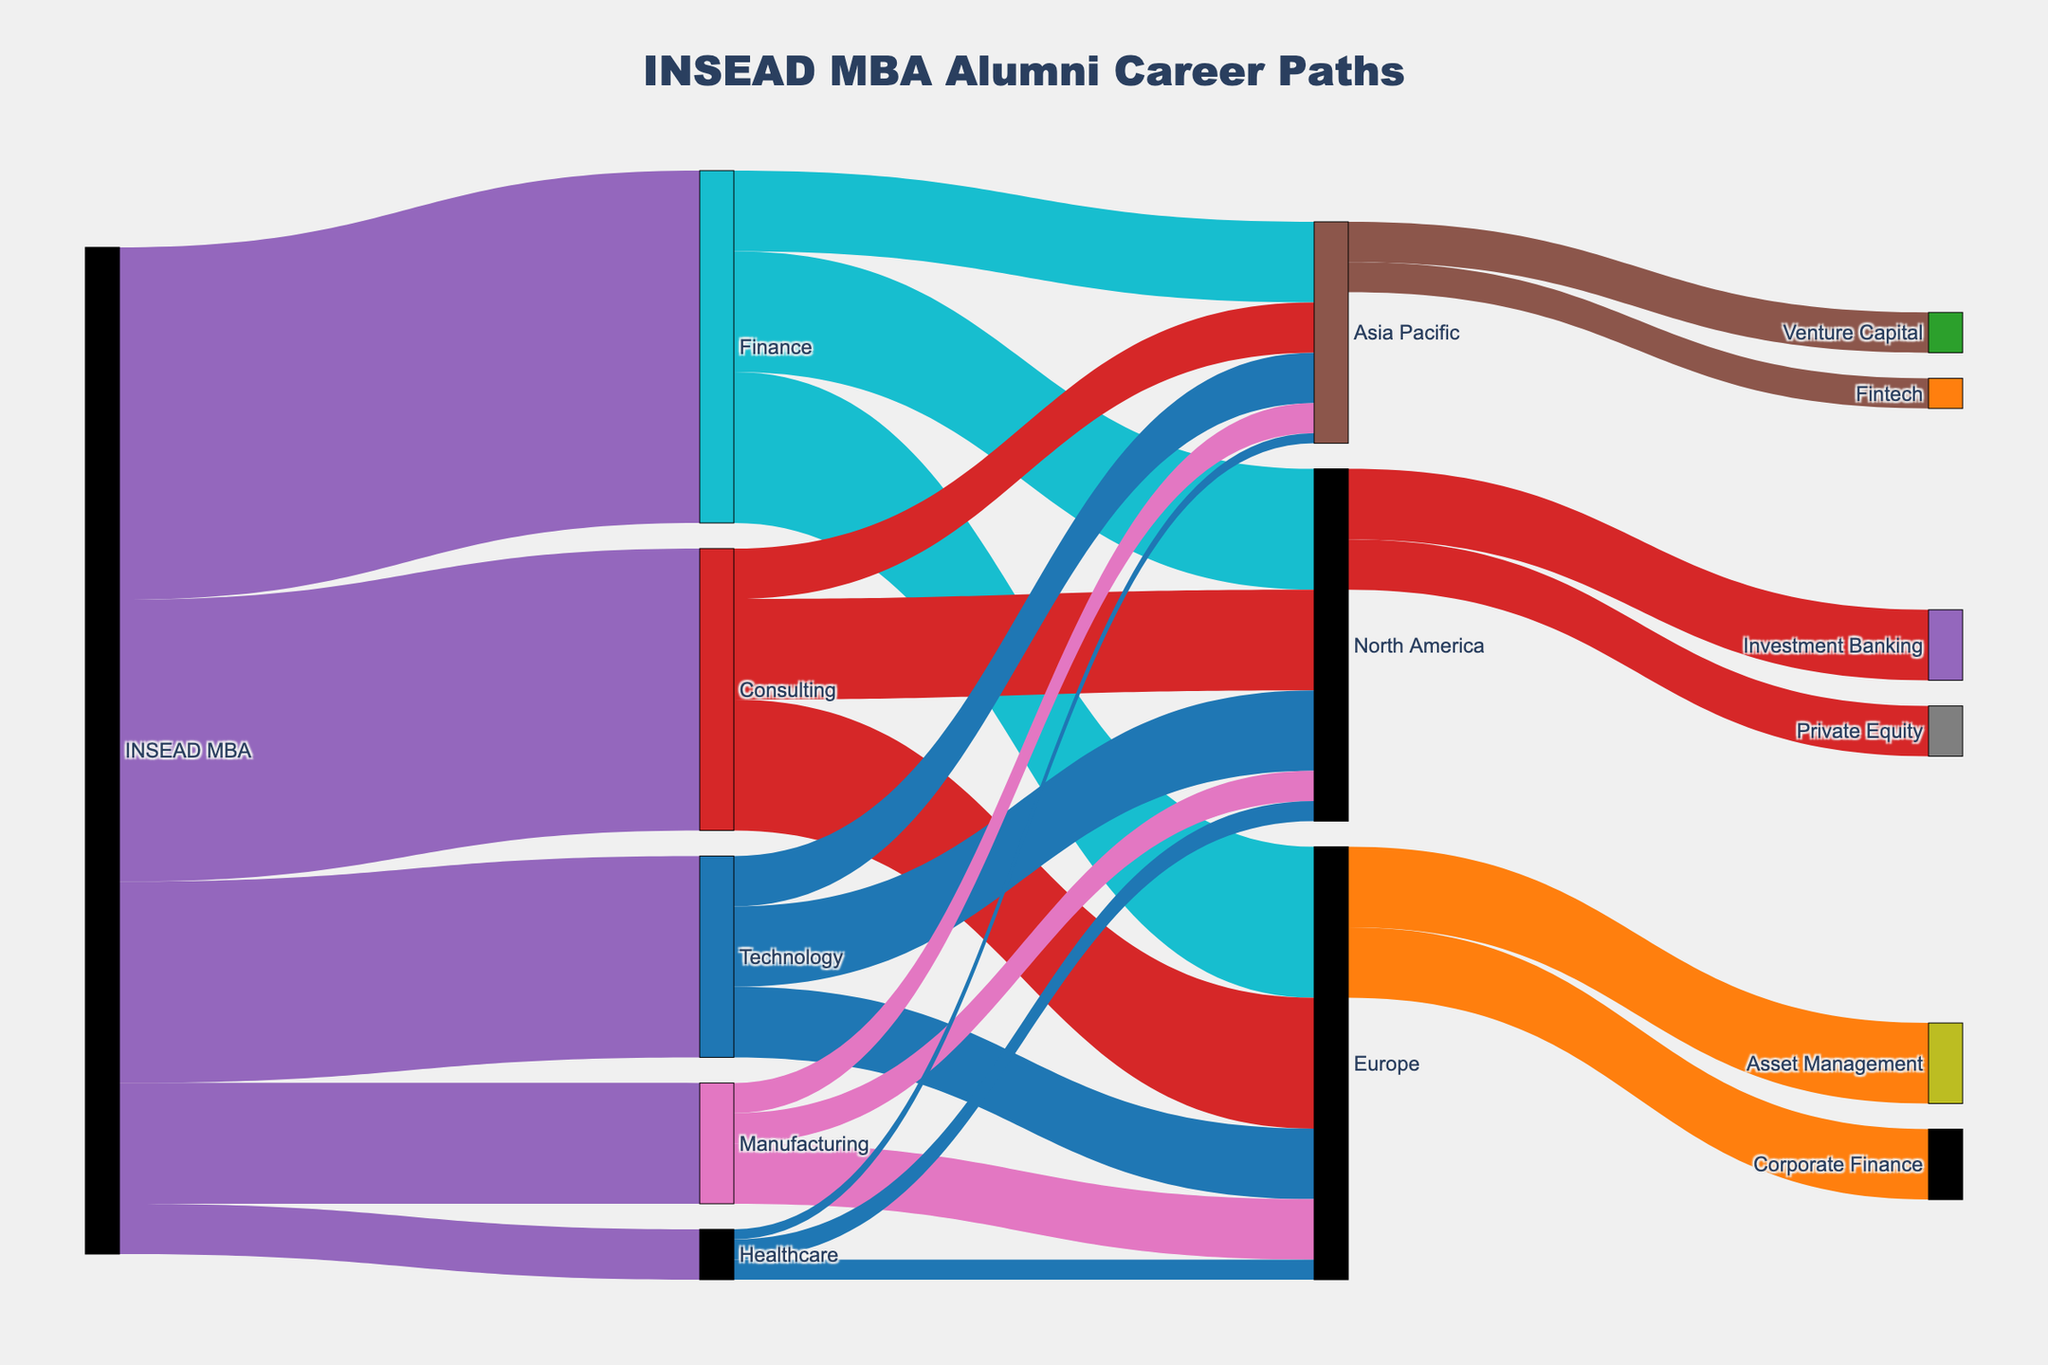what are the top three industries where INSEAD MBA alumni go? By examining the Sankey diagram, we can see the flows from "INSEAD MBA" to different industries. The three industries with the largest flows (highest values) connected to "INSEAD MBA" are Finance (350), Consulting (280), and Technology (200)
Answer: Finance, Consulting, Technology which region has the highest number of INSEAD MBA alumni working in the Consulting industry? Looking at the flows from "Consulting" to different regions, the values are Europe (130), North America (100), and Asia Pacific (50). Europe has the highest number of MBA alumni working in Consulting
Answer: Europe how many INSEAD MBA alumni are working in North America in the Finance and Technology industries combined? First, find the values of "Finance" to "North America" (120) and "Technology" to "North America" (80). Adding them together, we get 120 + 80 = 200
Answer: 200 where do the majority of Technology industry alumni end up region-wise? Examine the flows from "Technology" to different regions. The values are North America (80), Europe (70), and Asia Pacific (50). The majority go to North America
Answer: North America what is the combined value for INSEAD MBA alumni in Manufacturing industries across all regions? Look at the flows from "Manufacturing" to North America (30), Europe (60), and Asia Pacific (30). Adding these together, 30 + 60 + 30 = 120
Answer: 120 which specific financial sectors do INSEAD MBA alumni in Europe mainly enter? From the Sankey diagram, follow the flow from "Europe" in the Finance industry to specific financial sectors. Alumni enter Asset Management (80) and Corporate Finance (70)
Answer: Asset Management, Corporate Finance compare the number of alumni in the Consulting industry in Asia Pacific to those in North America. The values for Consulting in Asia Pacific and North America are 50 and 100, respectively. Comparing these, North America has more alumni
Answer: North America has more how many more INSEAD alumni are in the Healthcare industry in North America than in Asia Pacific? The values for Healthcare are North America (20) and Asia Pacific (10). Subtracting these, 20 - 10 = 10
Answer: 10 which industry has the least number of INSEAD MBA alumni? The source-node values directly from "INSEAD MBA" are compared. Healthcare, with a value of 50, is the least
Answer: Healthcare 